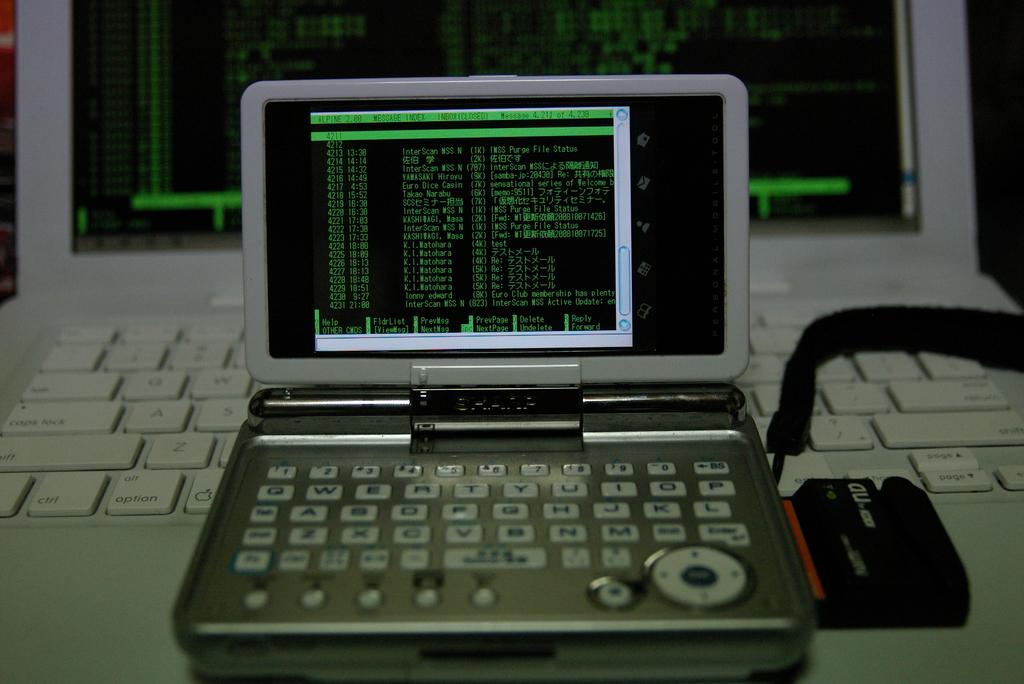What is the brand name of this gadge that is in the hinge?
Your response must be concise. Unanswerable. 